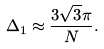<formula> <loc_0><loc_0><loc_500><loc_500>\Delta _ { 1 } \approx \frac { 3 \sqrt { 3 } \pi } { N } .</formula> 